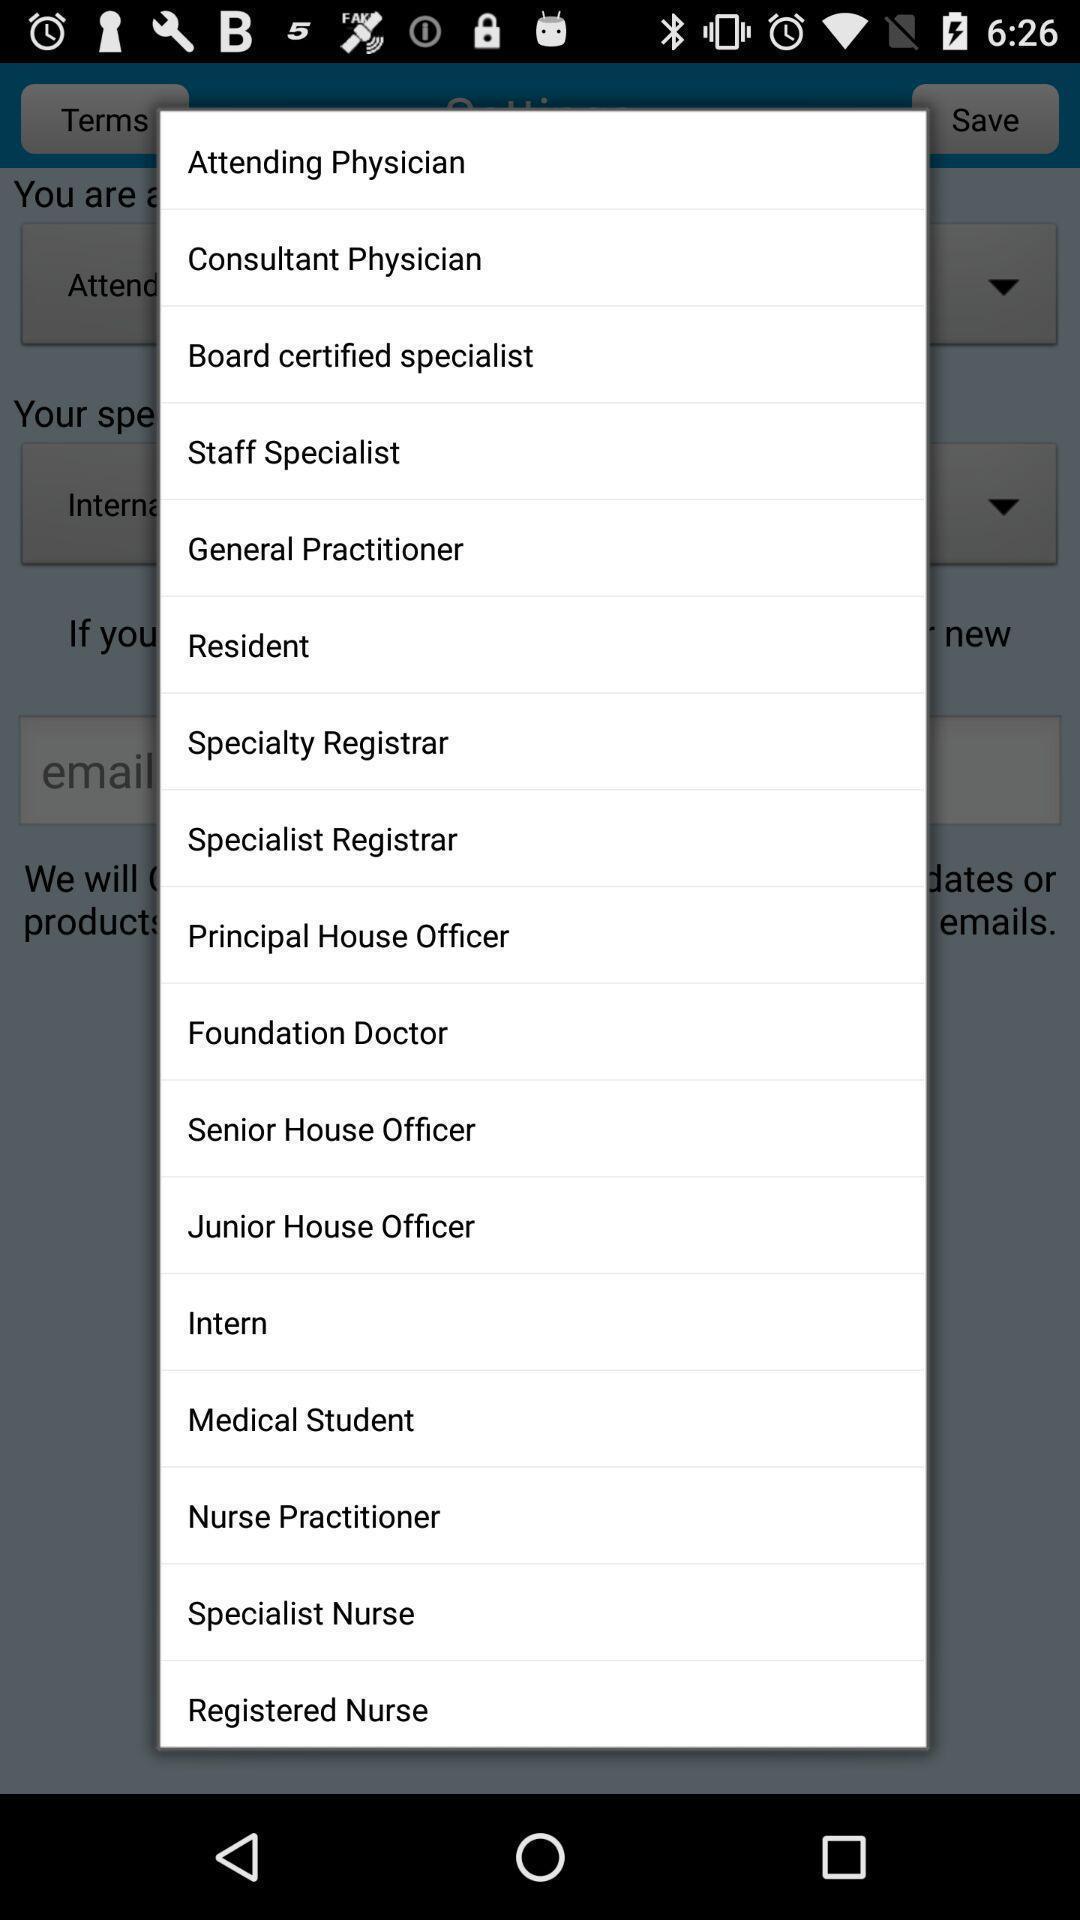Summarize the main components in this picture. Pop-up showing the listing of options. 